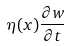Convert formula to latex. <formula><loc_0><loc_0><loc_500><loc_500>\eta ( x ) \frac { \partial w } { \partial t }</formula> 